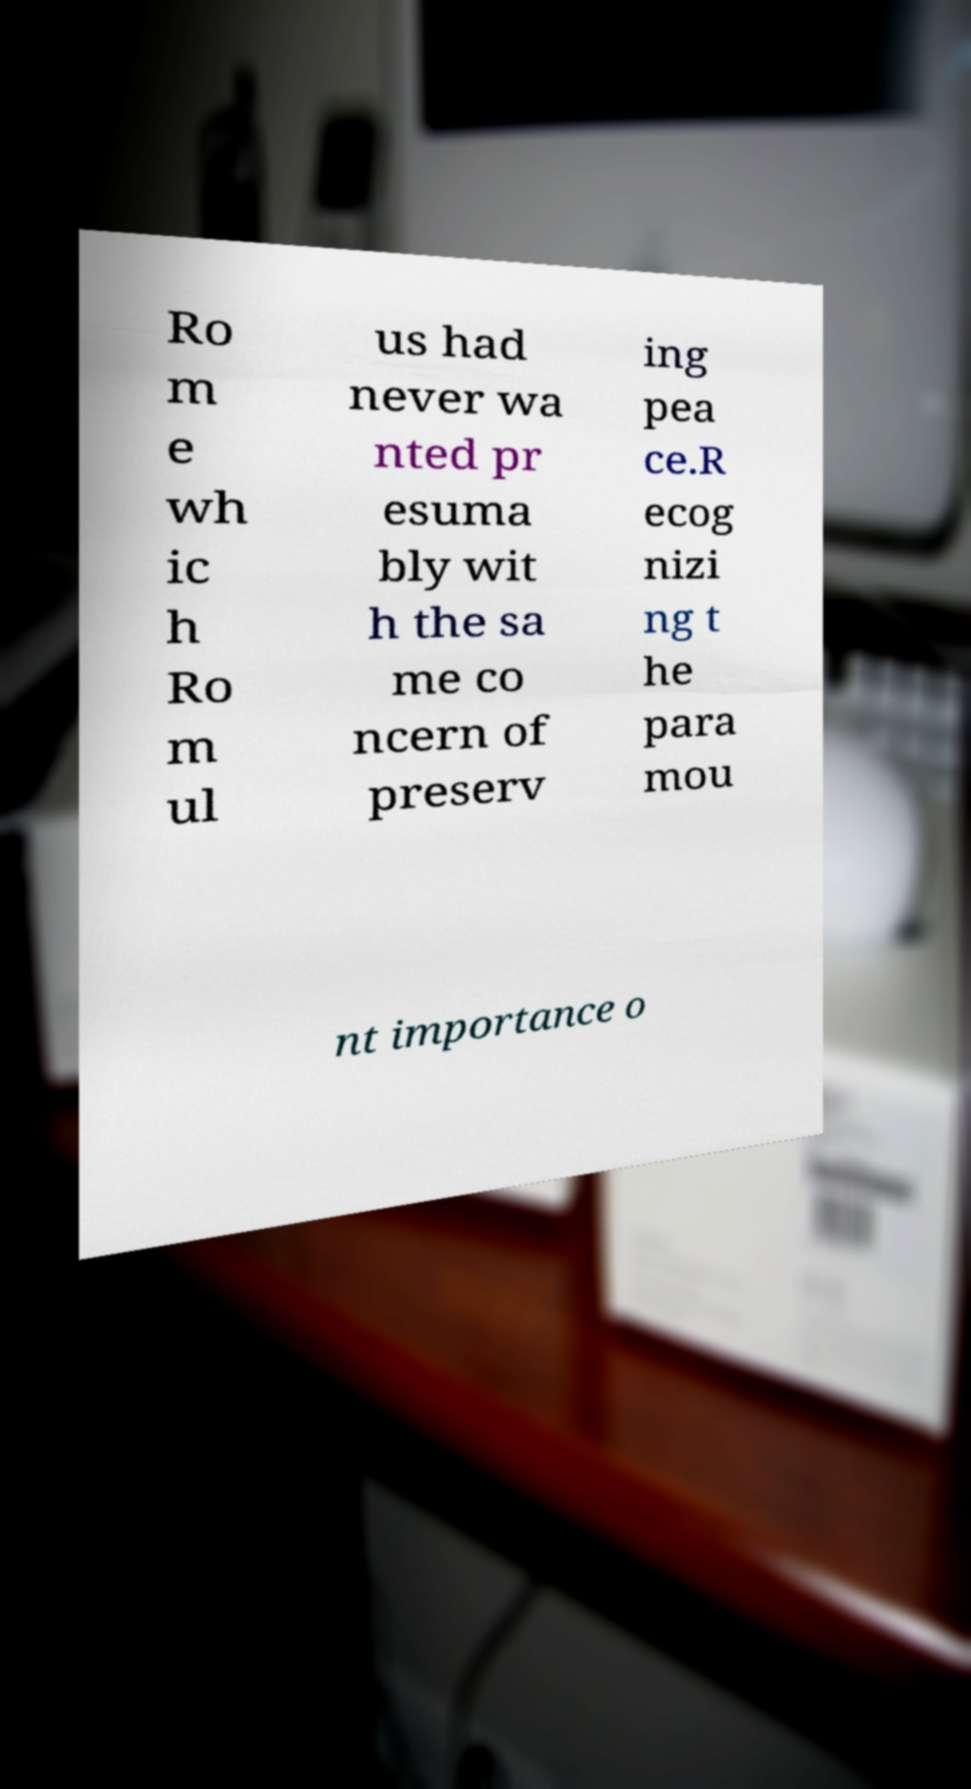Please read and relay the text visible in this image. What does it say? Ro m e wh ic h Ro m ul us had never wa nted pr esuma bly wit h the sa me co ncern of preserv ing pea ce.R ecog nizi ng t he para mou nt importance o 